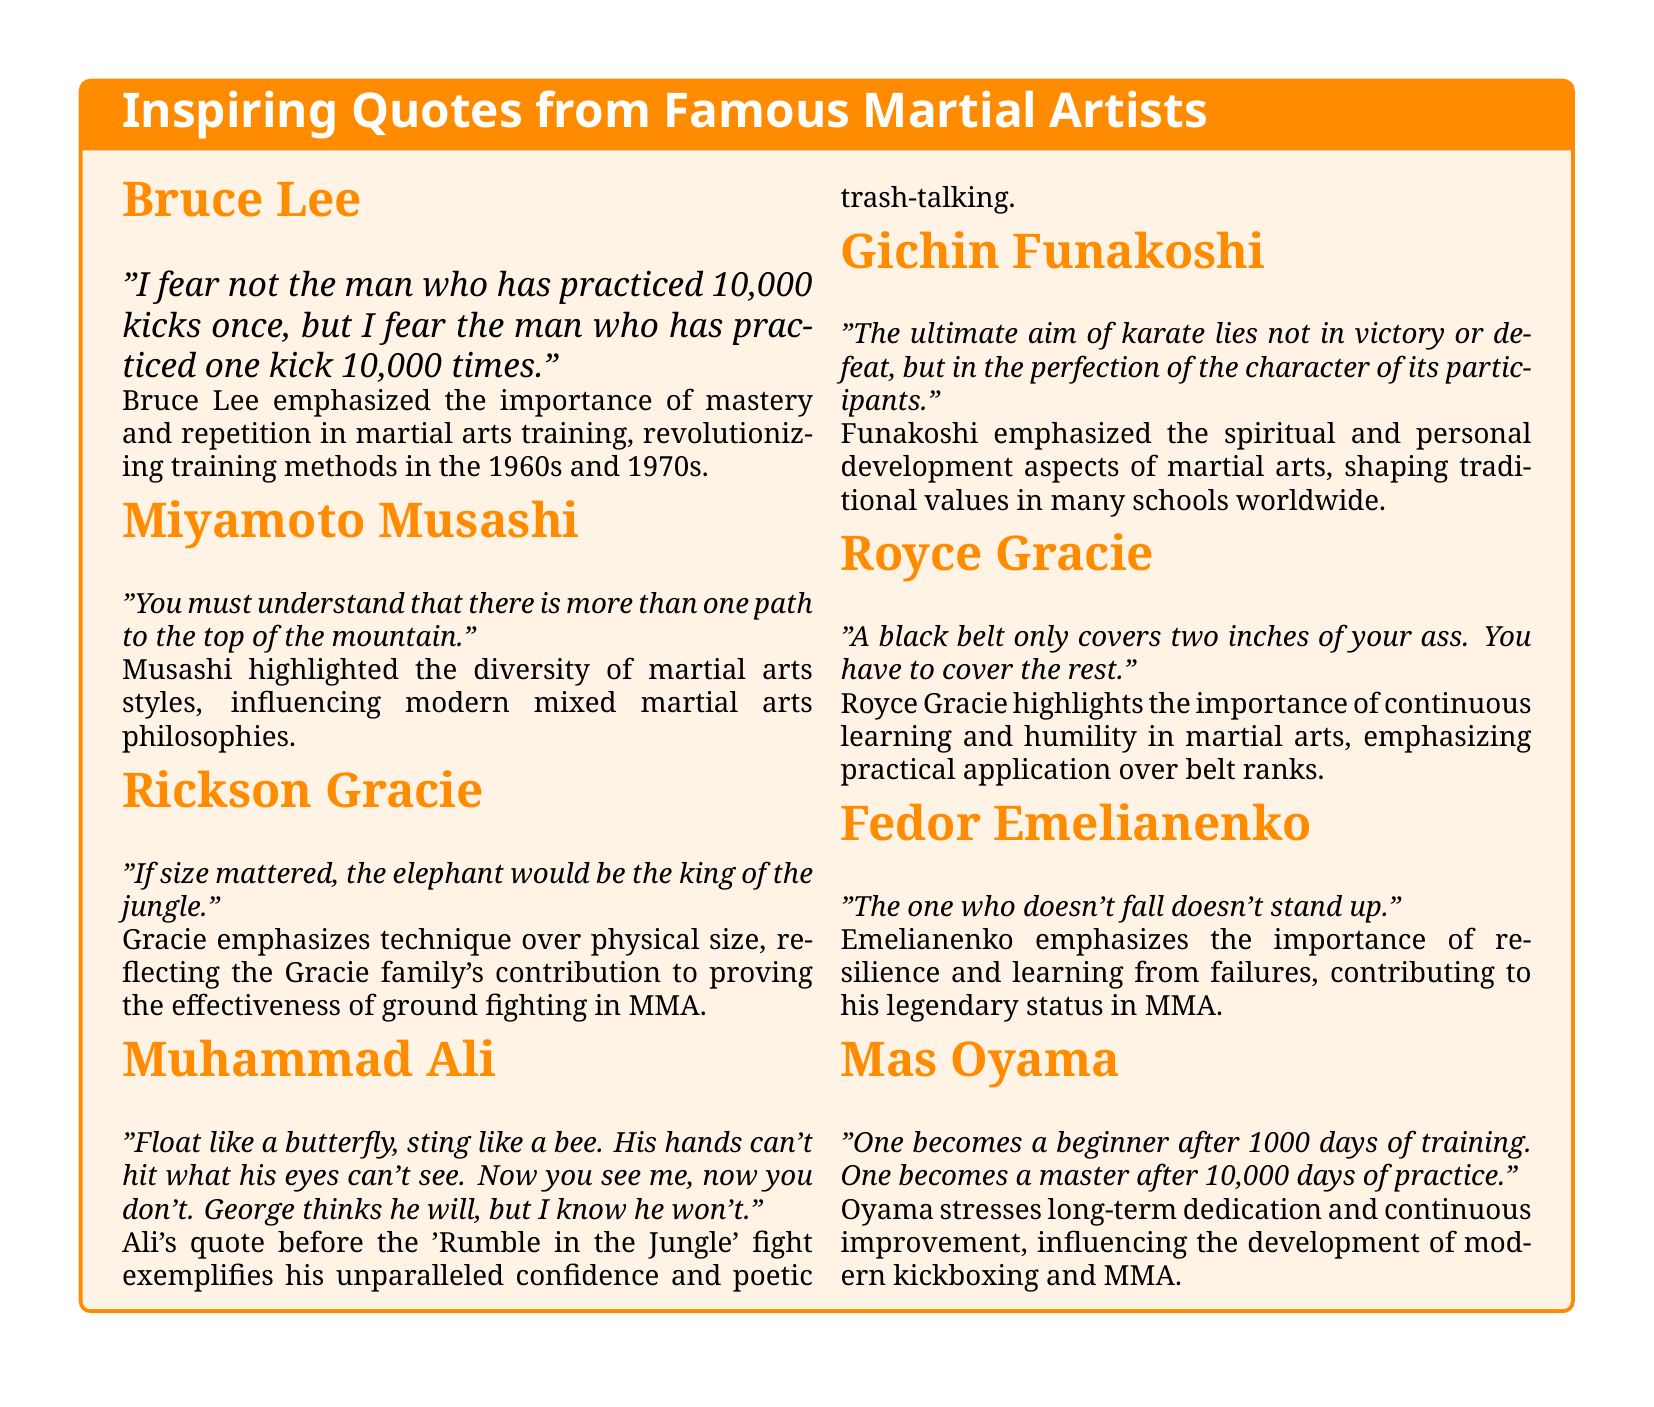What quote did Bruce Lee say about practice? Bruce Lee's quote emphasizes the significance of practicing one kick repeatedly rather than many techniques superficially.
Answer: "I fear not the man who has practiced 10,000 kicks once, but I fear the man who has practiced one kick 10,000 times." Who emphasized the importance of adaptability in martial arts? Miyamoto Musashi's quote highlights the need for open-mindedness and flexibility in combat sports.
Answer: Miyamoto Musashi What does Rickson Gracie's quote imply about size in martial arts? Rickson Gracie's statement indicates that technique is more important than physical size in fighting effectiveness.
Answer: "If size mattered, the elephant would be the king of the jungle." Which martial artist stated that the aim of karate is the perfection of character? Gichin Funakoshi's philosophy suggests that the spiritual development of participants is the ultimate aim of karate.
Answer: Gichin Funakoshi Who was the founder of Kyokushin Karate? The document mentions Mas Oyama as the founder of this martial arts style.
Answer: Mas Oyama What aspect of martial arts does Royce Gracie's quote address? Royce Gracie's quote stresses the necessity for continuous learning and humility, beyond just achieving a black belt.
Answer: Continuous learning and humility How many days of training does Mas Oyama say is needed to become a master? According to Mas Oyama, one needs 10,000 days of practice to reach mastery in martial arts.
Answer: 10,000 days What does Fedor Emelianenko's quote suggest about failure? Fedor Emelianenko's statement highlights that falling or failing is an essential part of standing up or succeeding.
Answer: Resilience and learning from failures 